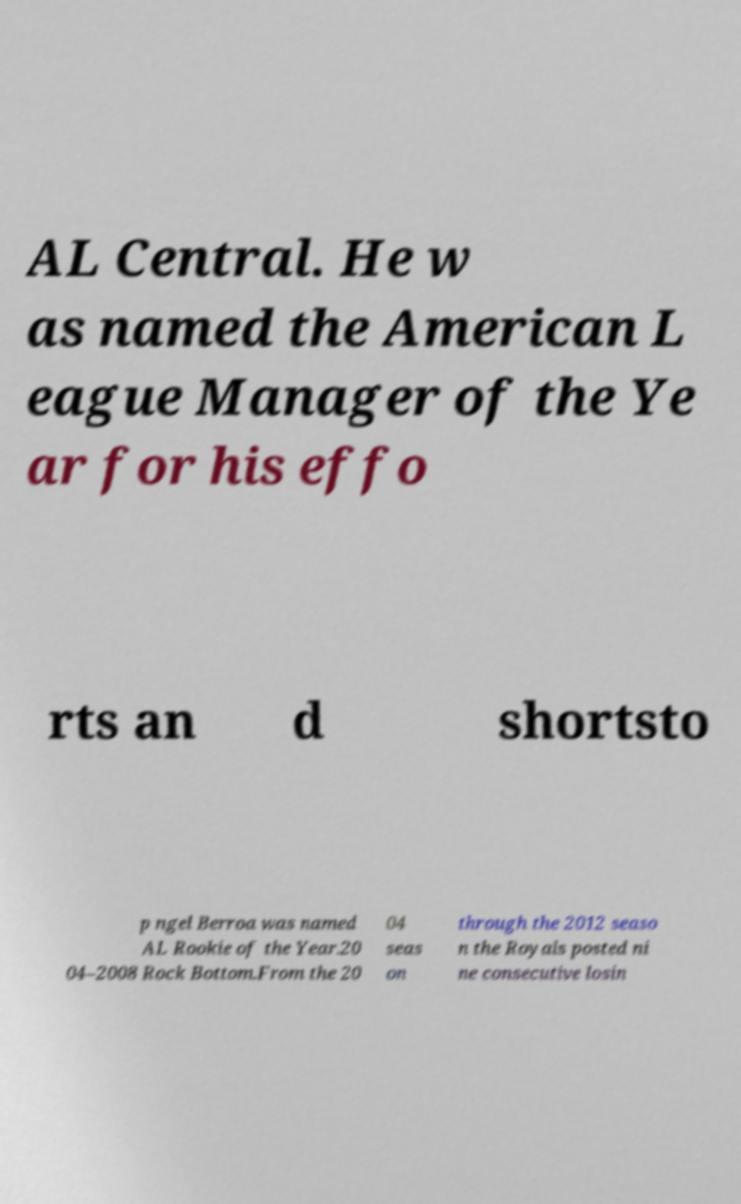I need the written content from this picture converted into text. Can you do that? AL Central. He w as named the American L eague Manager of the Ye ar for his effo rts an d shortsto p ngel Berroa was named AL Rookie of the Year.20 04–2008 Rock Bottom.From the 20 04 seas on through the 2012 seaso n the Royals posted ni ne consecutive losin 